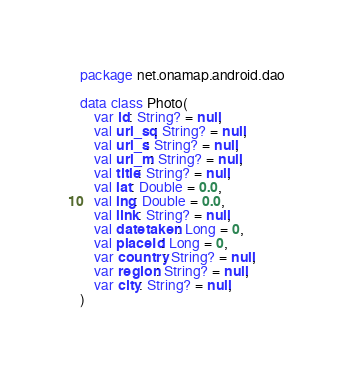Convert code to text. <code><loc_0><loc_0><loc_500><loc_500><_Kotlin_>package net.onamap.android.dao

data class Photo(
    var id: String? = null,
    val url_sq: String? = null,
    val url_s: String? = null,
    val url_m: String? = null,
    val title: String? = null,
    val lat: Double = 0.0,
    val lng: Double = 0.0,
    val link: String? = null,
    val datetaken: Long = 0,
    val placeId: Long = 0,
    var country: String? = null,
    var region: String? = null,
    var city: String? = null,
)</code> 